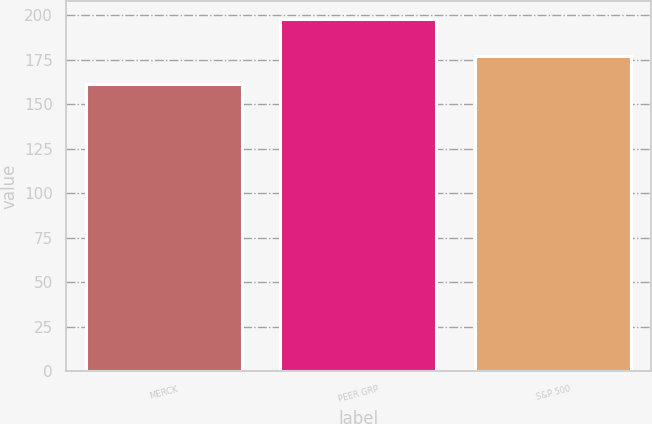<chart> <loc_0><loc_0><loc_500><loc_500><bar_chart><fcel>MERCK<fcel>PEER GRP<fcel>S&P 500<nl><fcel>161.33<fcel>197.89<fcel>176.95<nl></chart> 